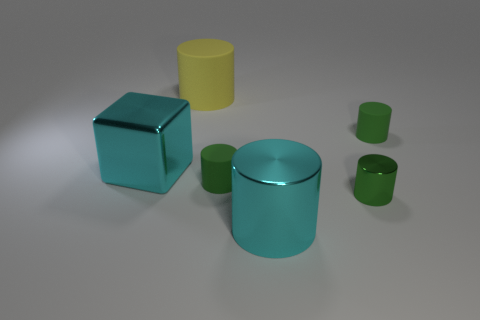How many things are matte cylinders or green objects?
Keep it short and to the point. 4. There is a green thing that is the same material as the cyan cylinder; what is its shape?
Your answer should be compact. Cylinder. What size is the cyan metallic thing that is in front of the big cyan object that is left of the big cyan cylinder?
Keep it short and to the point. Large. How many big objects are either green metal things or cylinders?
Make the answer very short. 2. What number of other things are the same color as the metallic block?
Keep it short and to the point. 1. Is the size of the cyan thing that is right of the yellow rubber thing the same as the shiny thing on the left side of the yellow rubber object?
Offer a very short reply. Yes. Do the block and the cyan object that is on the right side of the yellow object have the same material?
Make the answer very short. Yes. Are there more objects on the left side of the large cyan cylinder than cyan metallic cylinders to the right of the green shiny cylinder?
Ensure brevity in your answer.  Yes. What color is the rubber object behind the tiny object behind the big metallic cube?
Provide a short and direct response. Yellow. What number of blocks are either tiny green metal things or tiny green matte things?
Ensure brevity in your answer.  0. 